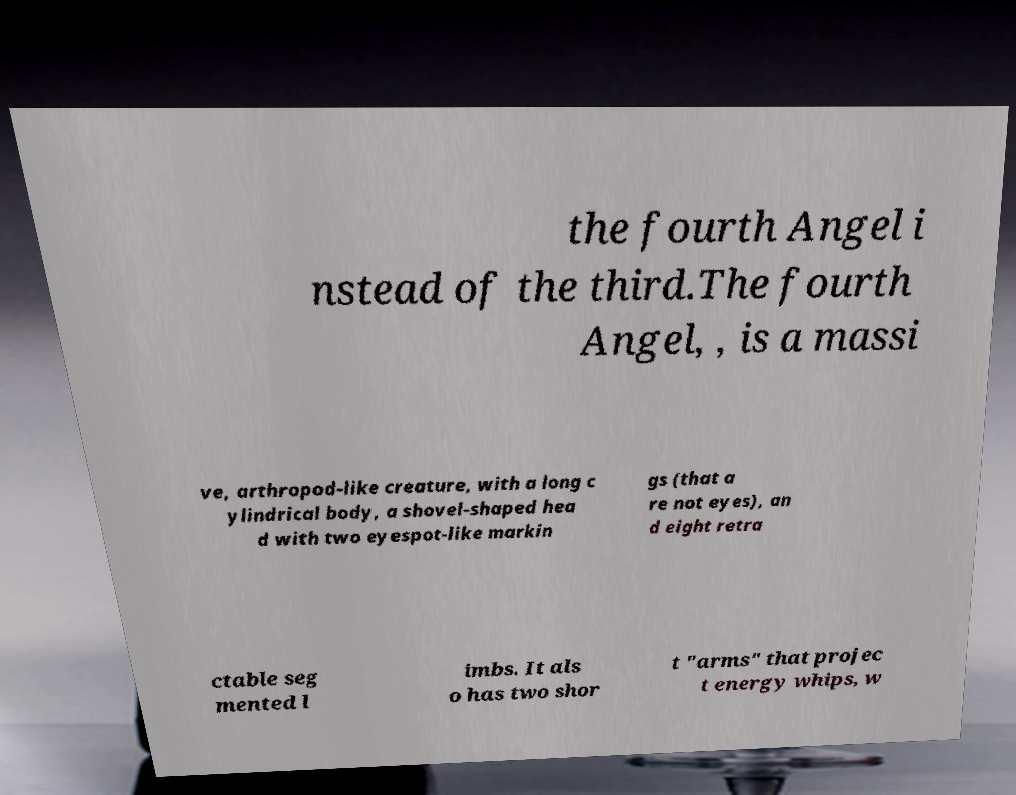What messages or text are displayed in this image? I need them in a readable, typed format. the fourth Angel i nstead of the third.The fourth Angel, , is a massi ve, arthropod-like creature, with a long c ylindrical body, a shovel-shaped hea d with two eyespot-like markin gs (that a re not eyes), an d eight retra ctable seg mented l imbs. It als o has two shor t "arms" that projec t energy whips, w 